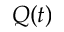<formula> <loc_0><loc_0><loc_500><loc_500>Q ( t )</formula> 